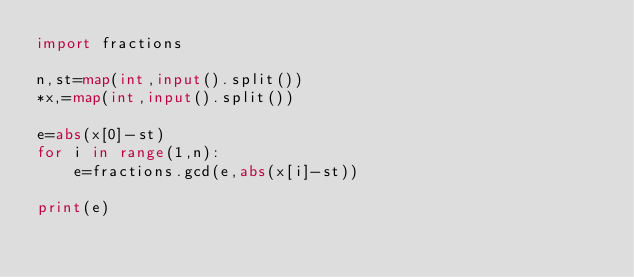Convert code to text. <code><loc_0><loc_0><loc_500><loc_500><_Python_>import fractions

n,st=map(int,input().split())
*x,=map(int,input().split())

e=abs(x[0]-st)
for i in range(1,n):
    e=fractions.gcd(e,abs(x[i]-st))

print(e)</code> 